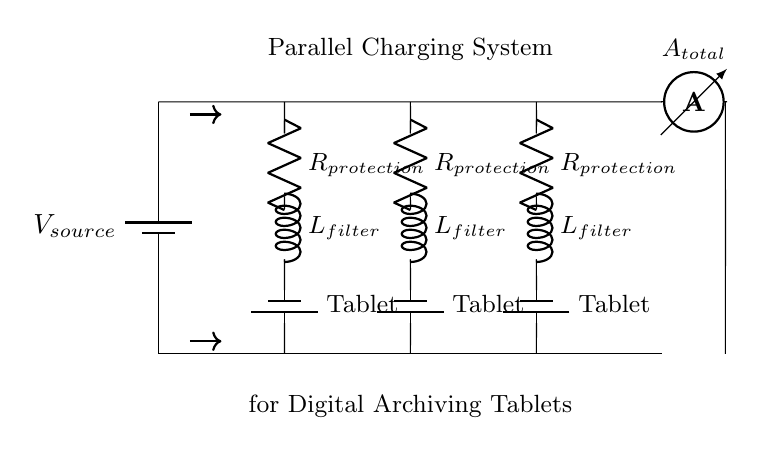What type of circuit is this? This circuit is a parallel circuit because multiple components (tablets) are connected in such a way that the same voltage is applied across each one independently.
Answer: Parallel What do the batteries represent? The batteries in the circuit represent the individual charge sources for each tablet, indicating that they receive power from the source to charge their batteries.
Answer: Tablets How many tablets can be charged simultaneously? There are three branches in the circuit, each with a tablet, meaning three tablets can be charged simultaneously.
Answer: Three What component is used for current protection? The component labeled as "R_protection" serves to limit or protect the circuit from excessive current, ensuring the tablets do not receive more current than they can handle.
Answer: Resistor What is the purpose of the inductor in each branch? The inductors labeled "L_filter" are used to filter out noise from the power supply, stabilizing the current and voltage supplied to the tablets for consistent charging performance.
Answer: Filter What is measured by the ammeter? The ammeter labeled "A_total" measures the total current flowing through the entire circuit, which is the sum of the currents supplied to each individual tablet branch.
Answer: Total current What is the voltage across all tablets? Since this is a parallel circuit, the voltage across all branches (tablets) is equal to the voltage of the source, which remains constant regardless of the number of tablets connected.
Answer: V_source 